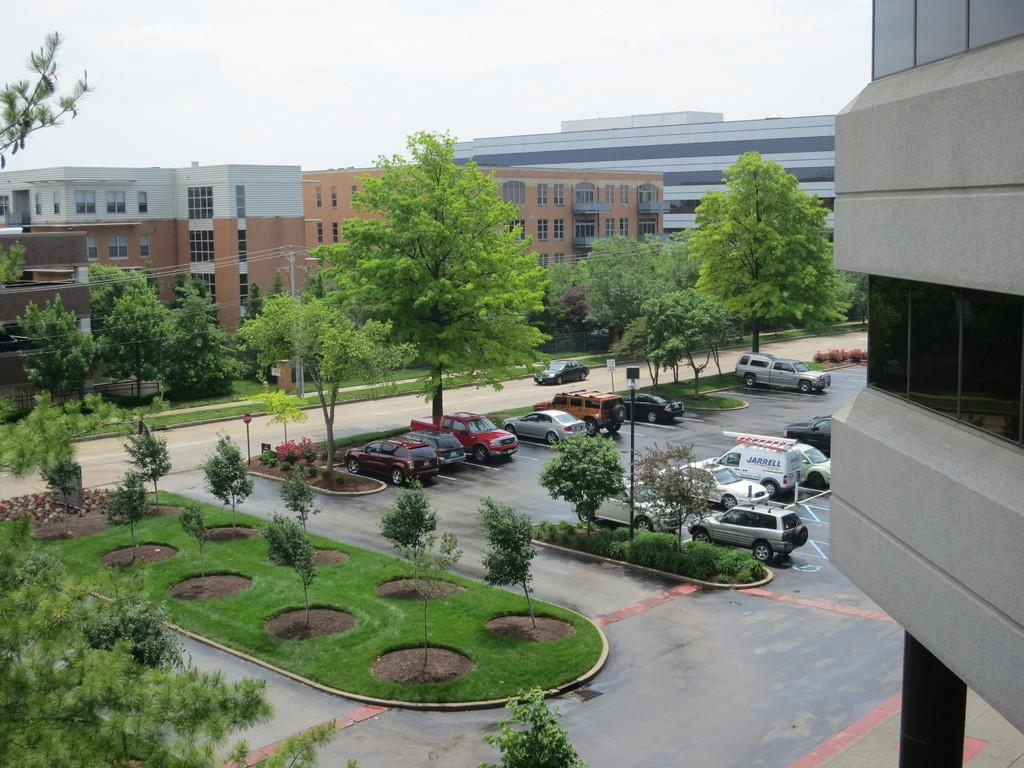What type of natural elements can be seen in the image? There are plants and trees in the image. What else can be seen in the image besides natural elements? There are parked vehicles in the image. What can be seen in the background of the image? There are buildings and the clear sky visible in the background of the image. What type of shoe is hanging from the tree in the image? There is no shoe hanging from the tree in the image; only plants, trees, parked vehicles, buildings, and the clear sky are visible. 